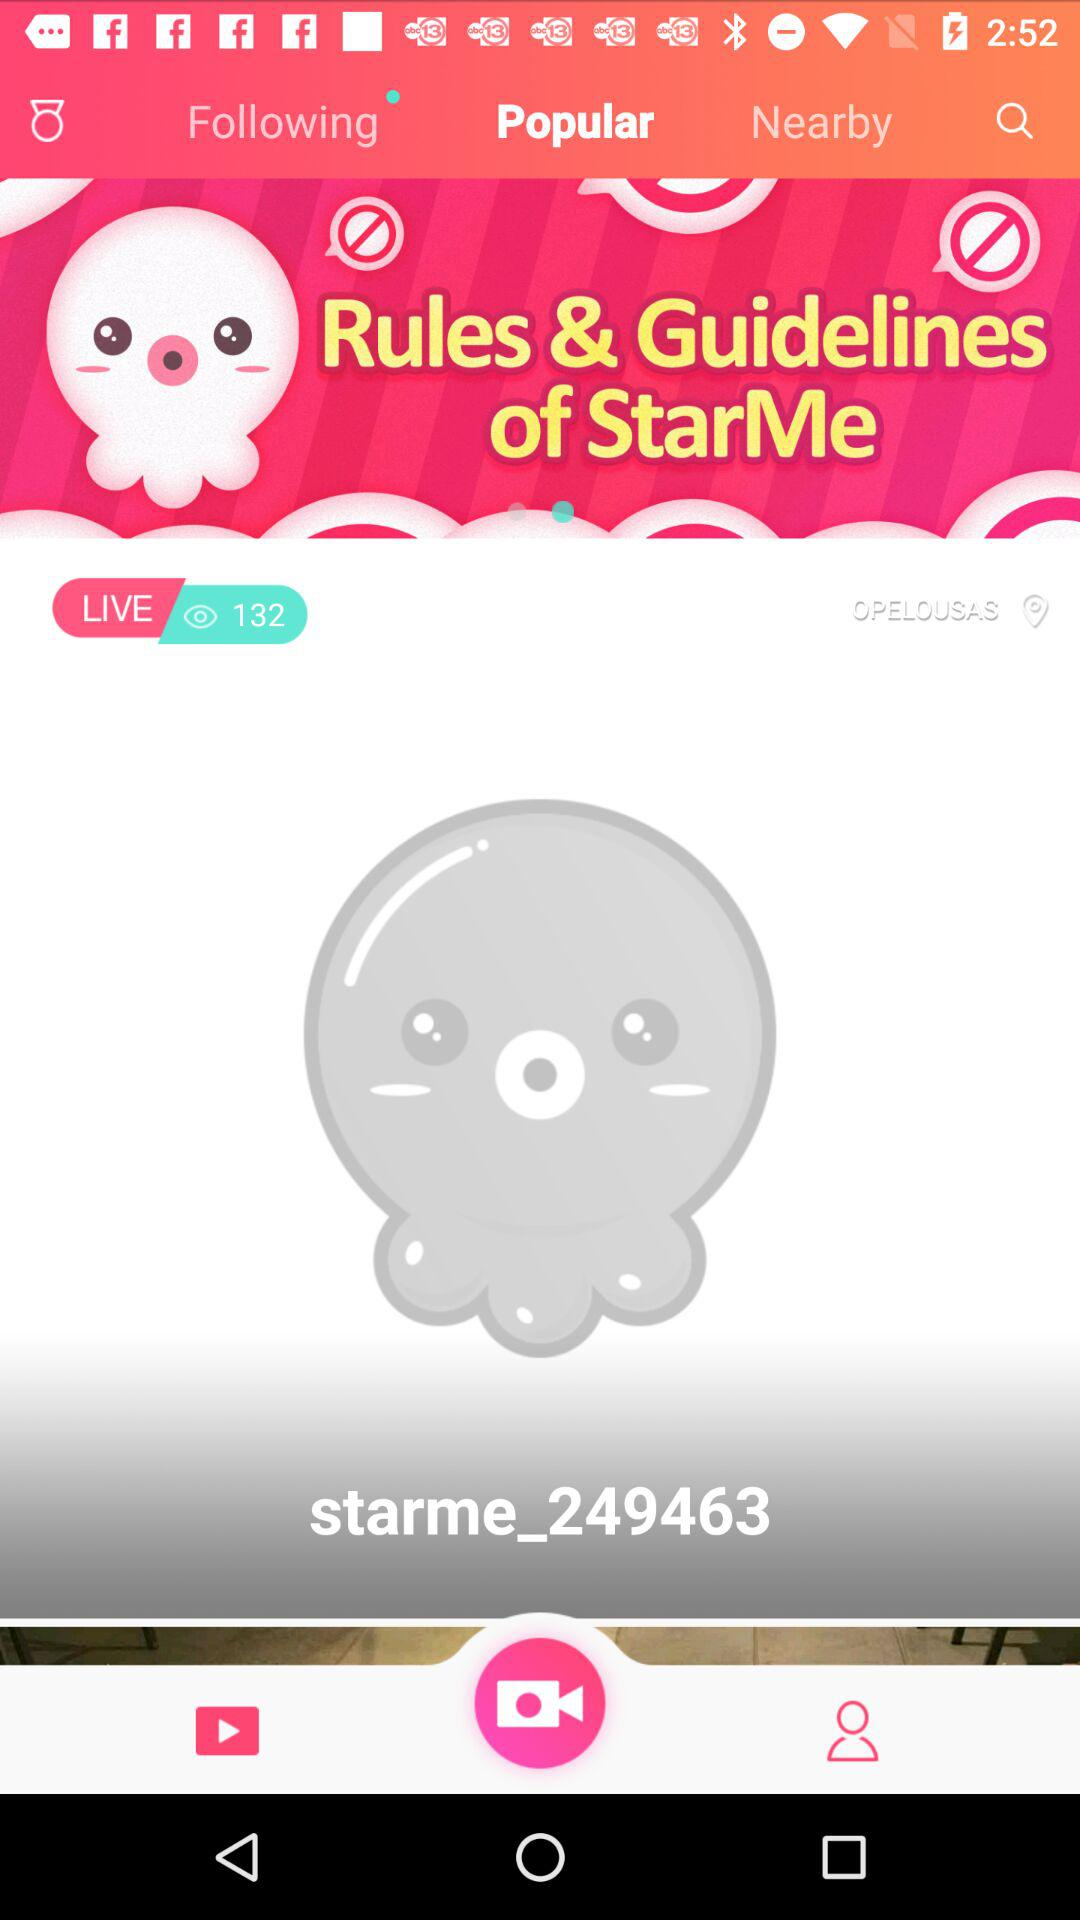What is the application name? The application name is "StarMe". 